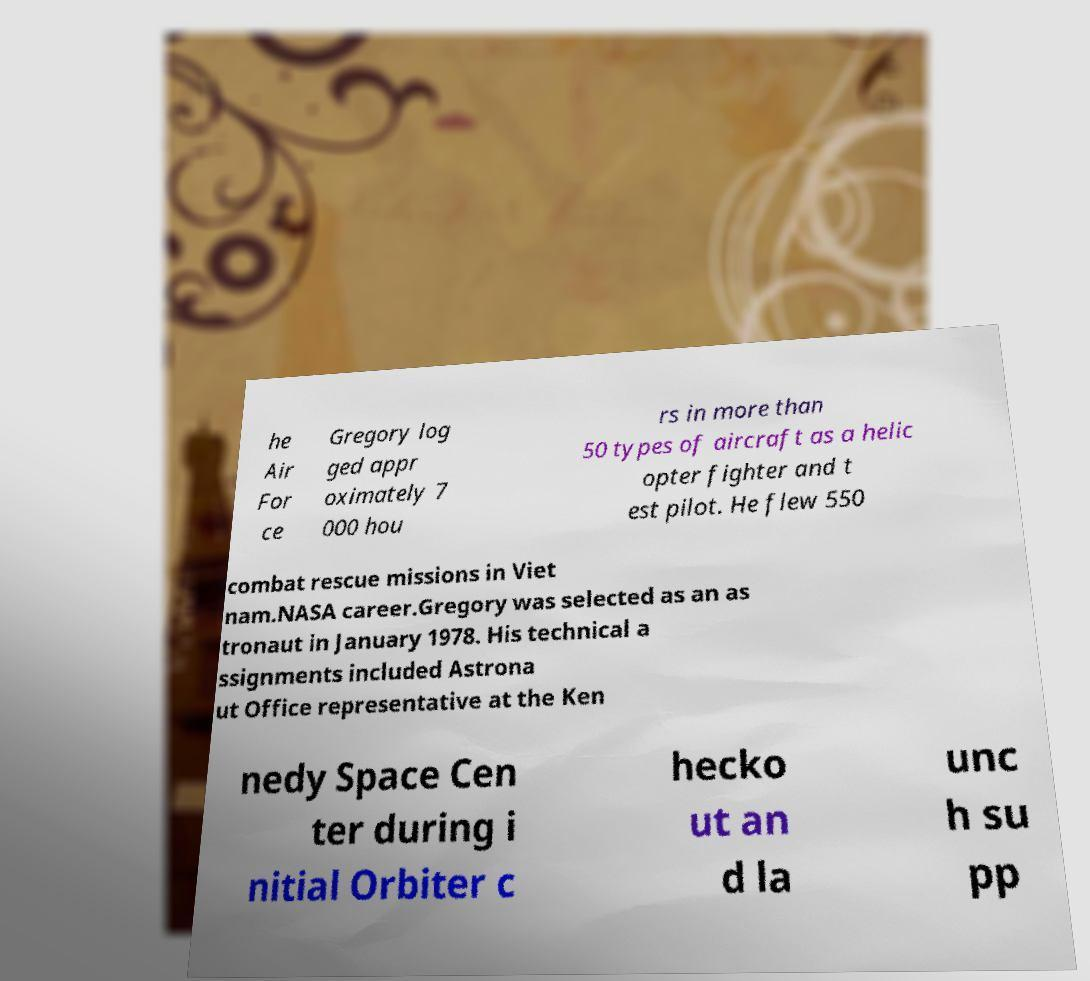Can you accurately transcribe the text from the provided image for me? he Air For ce Gregory log ged appr oximately 7 000 hou rs in more than 50 types of aircraft as a helic opter fighter and t est pilot. He flew 550 combat rescue missions in Viet nam.NASA career.Gregory was selected as an as tronaut in January 1978. His technical a ssignments included Astrona ut Office representative at the Ken nedy Space Cen ter during i nitial Orbiter c hecko ut an d la unc h su pp 